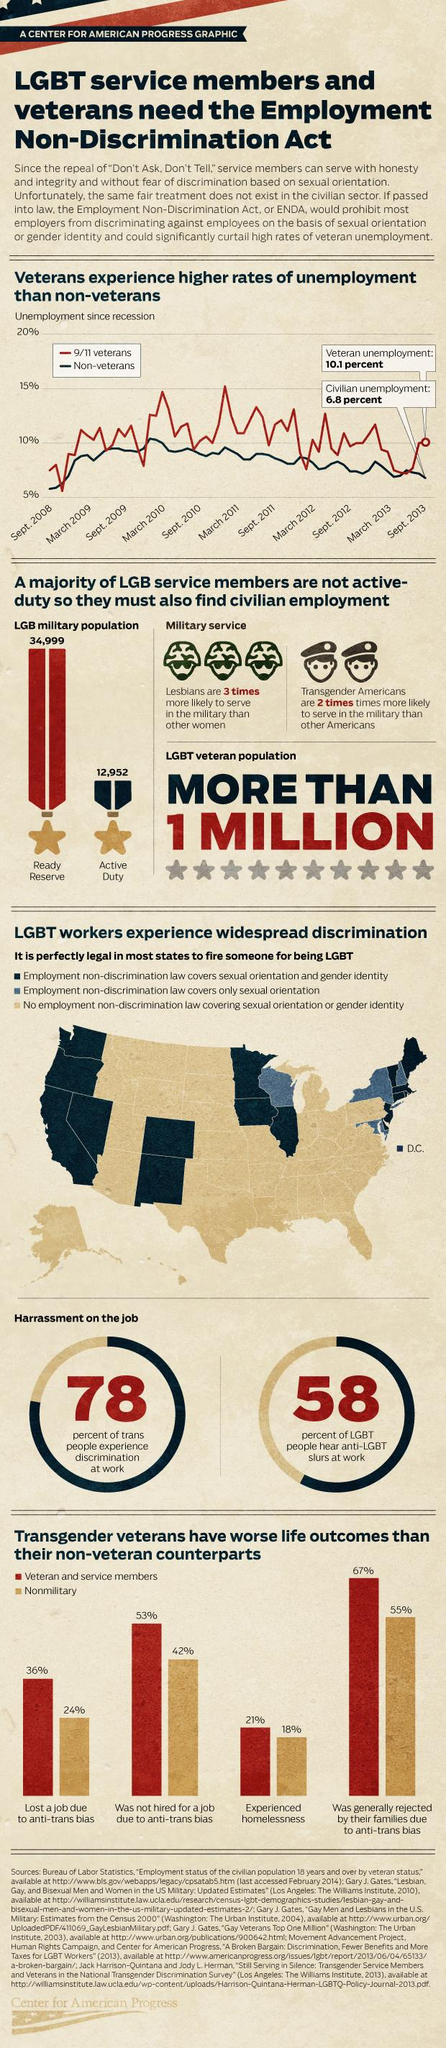Outline some significant characteristics in this image. According to a recent study, 21% of veteran and service members experienced homelessness. The unemployment rate of 9/11 veterans reached its peak in March 2011. According to data as of September 2013, 9/11 veterans had the highest rate of unemployment among all groups. Nearly 55% of the transgender individuals in the study who were part of the nonmilitary group were rejected by their families due to anti-trans bias. According to the data, a significant 24% of non-military individuals who have experienced anti-trans bias have lost their jobs as a result. 